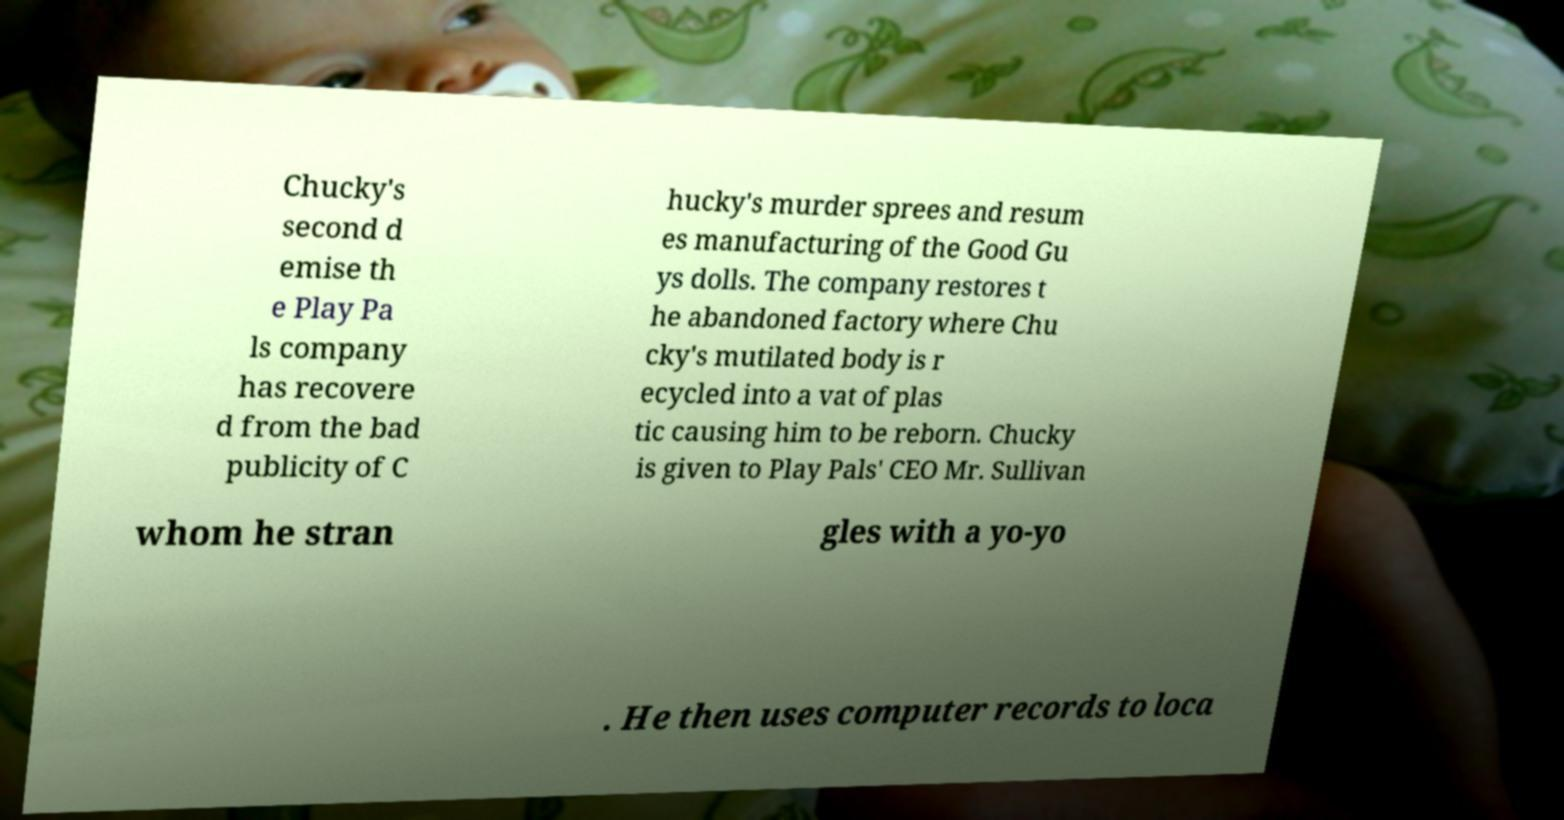There's text embedded in this image that I need extracted. Can you transcribe it verbatim? Chucky's second d emise th e Play Pa ls company has recovere d from the bad publicity of C hucky's murder sprees and resum es manufacturing of the Good Gu ys dolls. The company restores t he abandoned factory where Chu cky's mutilated body is r ecycled into a vat of plas tic causing him to be reborn. Chucky is given to Play Pals' CEO Mr. Sullivan whom he stran gles with a yo-yo . He then uses computer records to loca 